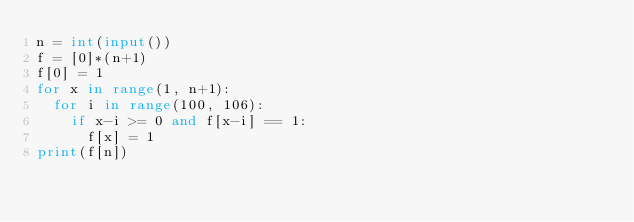Convert code to text. <code><loc_0><loc_0><loc_500><loc_500><_Python_>n = int(input())
f = [0]*(n+1)
f[0] = 1
for x in range(1, n+1):
	for i in range(100, 106):
		if x-i >= 0 and f[x-i] == 1:
			f[x] = 1
print(f[n])</code> 